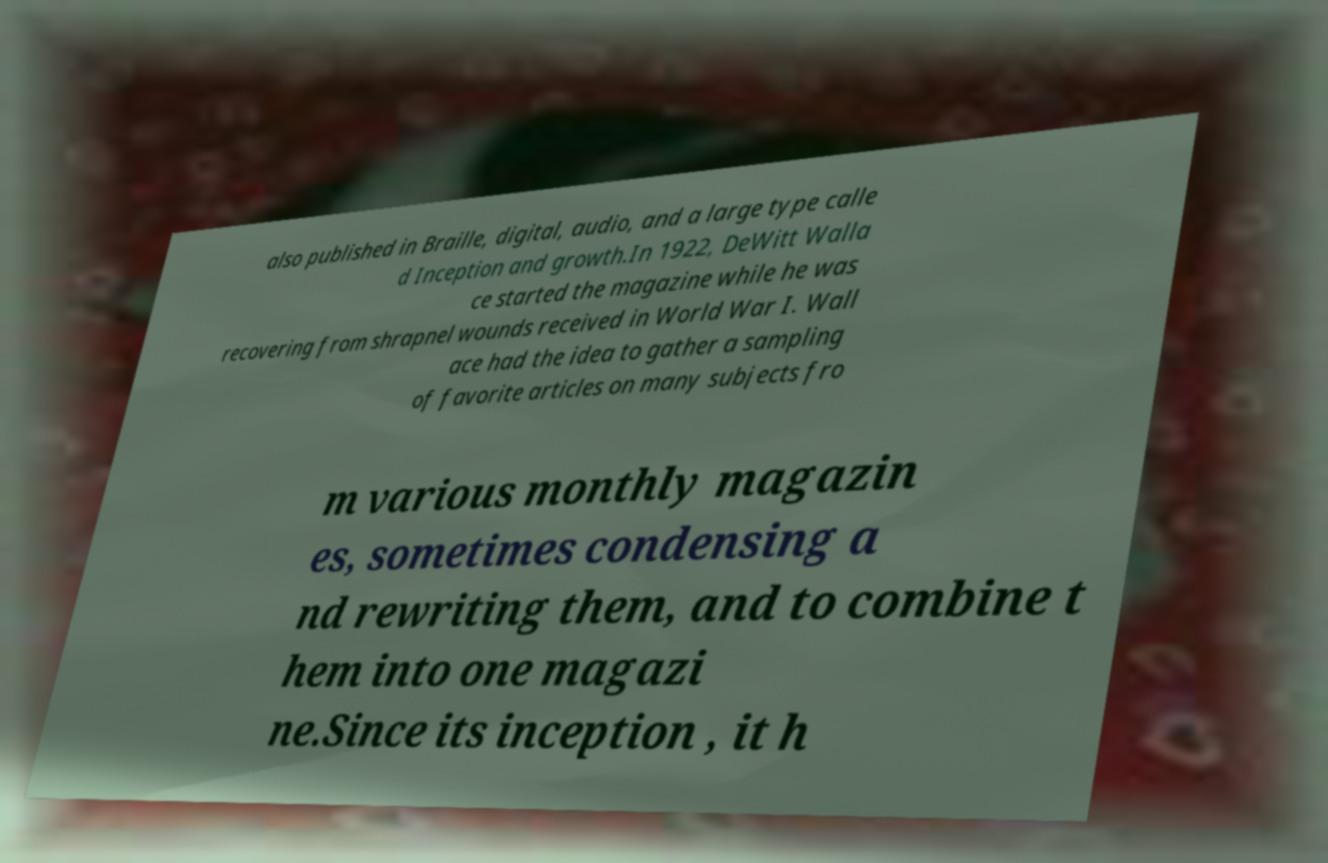Can you read and provide the text displayed in the image?This photo seems to have some interesting text. Can you extract and type it out for me? also published in Braille, digital, audio, and a large type calle d Inception and growth.In 1922, DeWitt Walla ce started the magazine while he was recovering from shrapnel wounds received in World War I. Wall ace had the idea to gather a sampling of favorite articles on many subjects fro m various monthly magazin es, sometimes condensing a nd rewriting them, and to combine t hem into one magazi ne.Since its inception , it h 